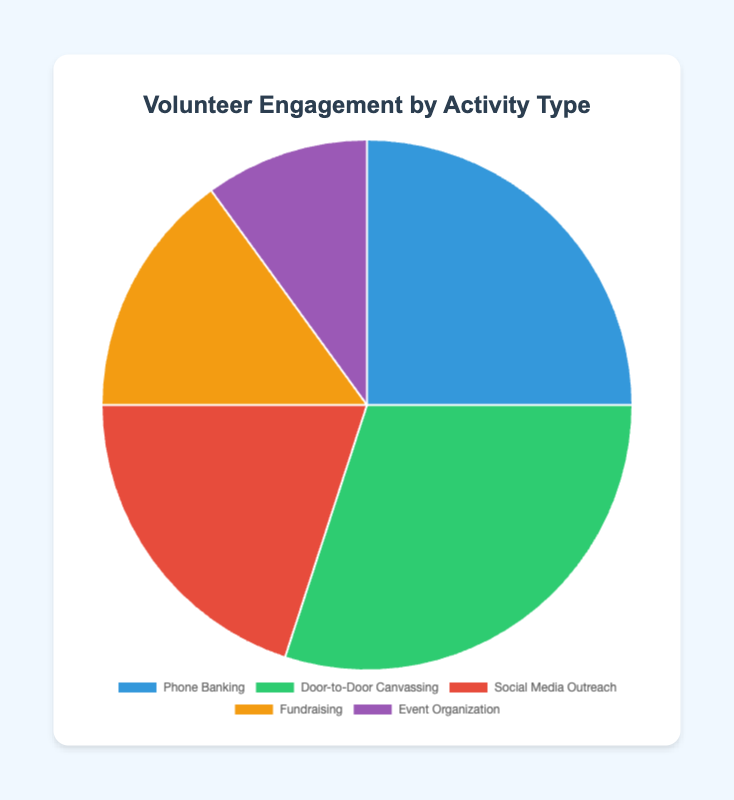What activity type engages the most volunteers? The activity type with the largest percentage in the pie chart is the one that engages the most volunteers. Door-to-Door Canvassing has the highest percentage at 30%.
Answer: Door-to-Door Canvassing What is the combined percentage of volunteers engaged in Phone Banking and Door-to-Door Canvassing? Add the percentages of Phone Banking (25%) and Door-to-Door Canvassing (30%). 25% + 30% = 55%
Answer: 55% Which activity type engages less volunteers compared to Social Media Outreach? Compare the percentages of Social Media Outreach (20%) with other activities. Fundraising (15%) and Event Organization (10%) both have lower percentages.
Answer: Fundraising and Event Organization By how much does Door-to-Door Canvassing surpass Event Organization in terms of volunteer engagement? Subtract the percentage of Event Organization (10%) from Door-to-Door Canvassing (30%). 30% - 10% = 20%
Answer: 20% Arrange the activities in order of decreasing volunteer engagement. Order the activities based on their percentages from highest to lowest. The order is: Door-to-Door Canvassing (30%), Phone Banking (25%), Social Media Outreach (20%), Fundraising (15%), Event Organization (10%).
Answer: Door-to-Door Canvassing, Phone Banking, Social Media Outreach, Fundraising, Event Organization What is the percentage difference between the highest and the lowest volunteer engagement activities? Subtract the percentage of the lowest engagement activity (Event Organization at 10%) from the highest engagement activity (Door-to-Door Canvassing at 30%). 30% - 10% = 20%
Answer: 20% What fraction of volunteers are engaged in either Fundraising or Event Organization combined? Add the percentages of Fundraising (15%) and Event Organization (10%) and then convert the sum into a fraction. 15% + 10% = 25%, which is 25/100 or 1/4.
Answer: 1/4 If the total number of volunteers is 1,000, how many volunteers are engaged in Social Media Outreach? Multiply the total number of volunteers (1,000) by the percentage engaged in Social Media Outreach (20%). 1,000 * 20% = 200
Answer: 200 What color represents Fundraising in the pie chart? The color corresponding to Fundraising in the pie chart is visually distinguishable. It is "yellow" (or a shade close to yellow in the provided colors).
Answer: Yellow 